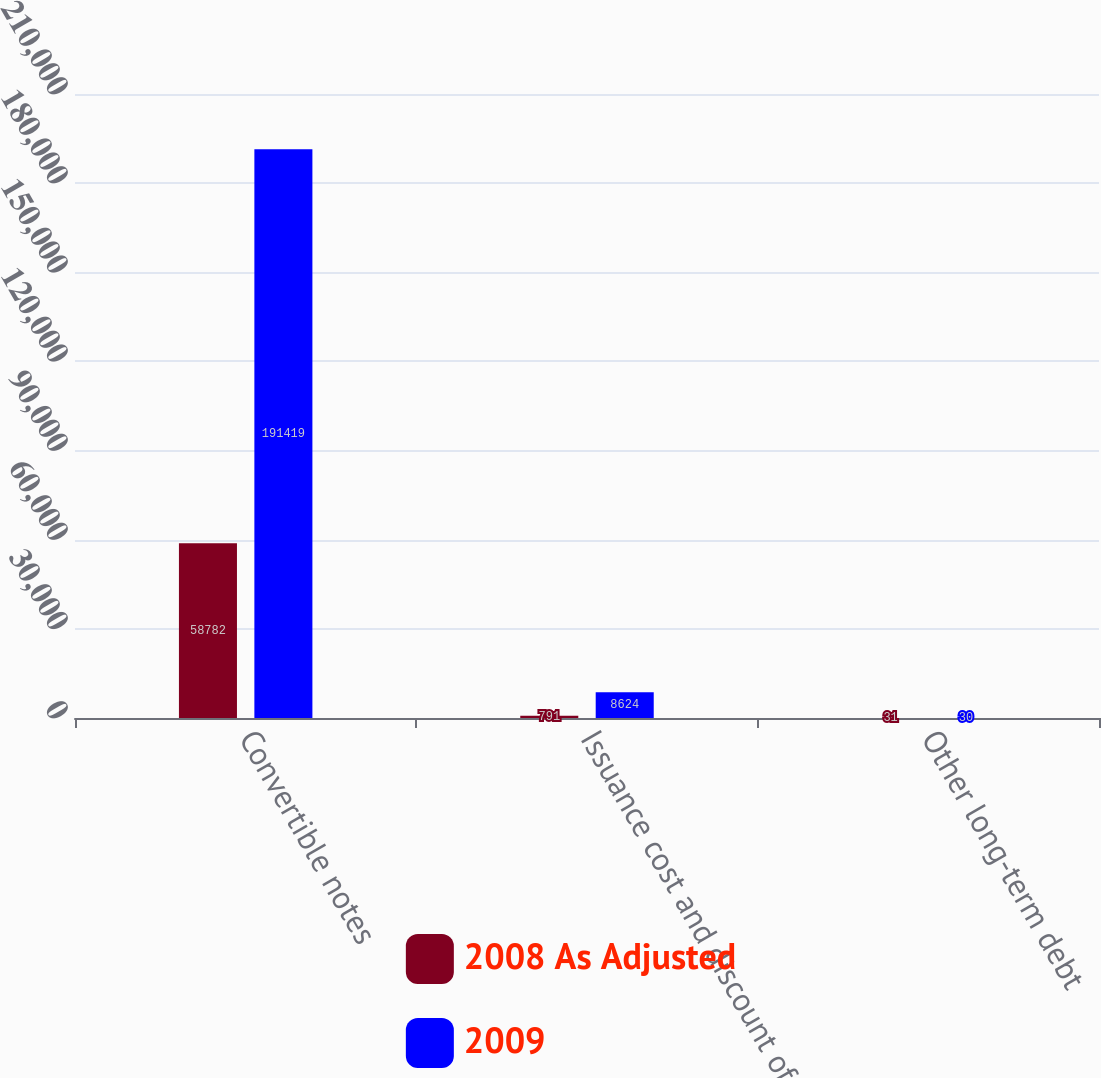Convert chart to OTSL. <chart><loc_0><loc_0><loc_500><loc_500><stacked_bar_chart><ecel><fcel>Convertible notes<fcel>Issuance cost and discount of<fcel>Other long-term debt<nl><fcel>2008 As Adjusted<fcel>58782<fcel>791<fcel>31<nl><fcel>2009<fcel>191419<fcel>8624<fcel>30<nl></chart> 